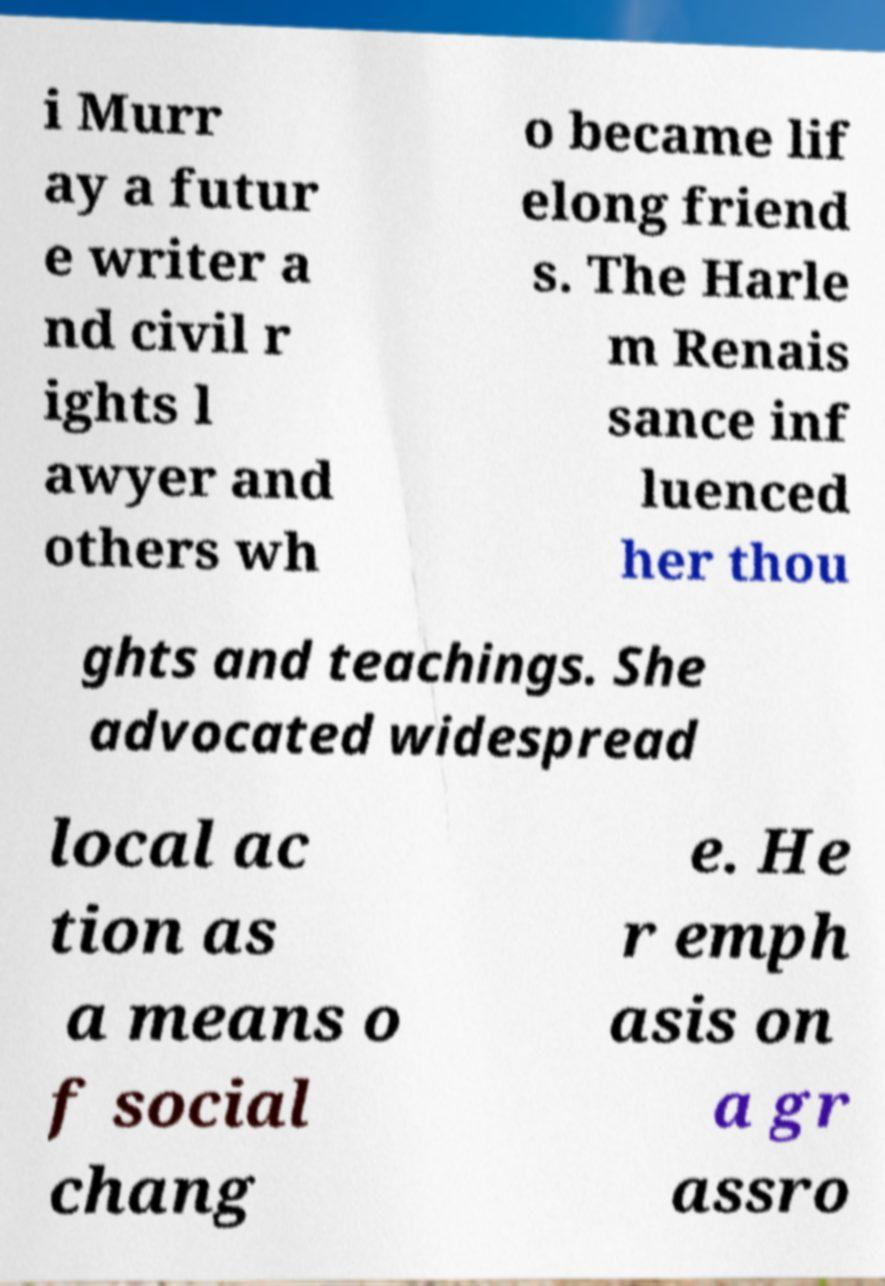What messages or text are displayed in this image? I need them in a readable, typed format. i Murr ay a futur e writer a nd civil r ights l awyer and others wh o became lif elong friend s. The Harle m Renais sance inf luenced her thou ghts and teachings. She advocated widespread local ac tion as a means o f social chang e. He r emph asis on a gr assro 